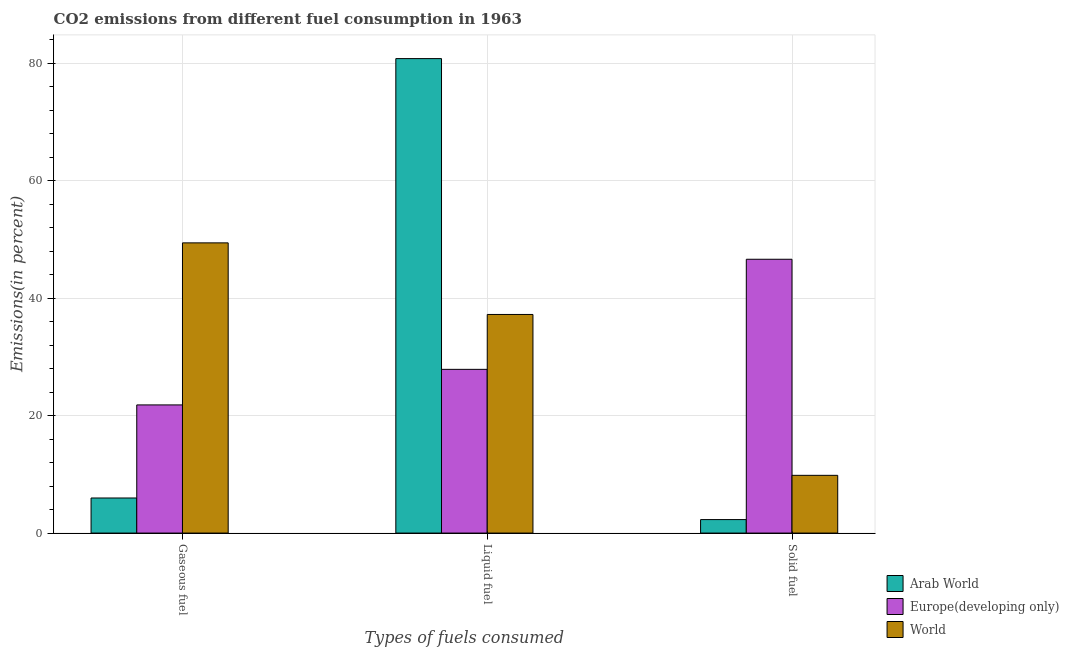How many different coloured bars are there?
Offer a very short reply. 3. Are the number of bars per tick equal to the number of legend labels?
Your answer should be very brief. Yes. Are the number of bars on each tick of the X-axis equal?
Offer a very short reply. Yes. What is the label of the 2nd group of bars from the left?
Offer a very short reply. Liquid fuel. What is the percentage of liquid fuel emission in Arab World?
Your response must be concise. 80.82. Across all countries, what is the maximum percentage of liquid fuel emission?
Offer a terse response. 80.82. Across all countries, what is the minimum percentage of liquid fuel emission?
Your response must be concise. 27.89. In which country was the percentage of liquid fuel emission maximum?
Offer a terse response. Arab World. In which country was the percentage of solid fuel emission minimum?
Make the answer very short. Arab World. What is the total percentage of solid fuel emission in the graph?
Offer a terse response. 58.77. What is the difference between the percentage of gaseous fuel emission in Arab World and that in Europe(developing only)?
Make the answer very short. -15.85. What is the difference between the percentage of gaseous fuel emission in Europe(developing only) and the percentage of liquid fuel emission in Arab World?
Provide a short and direct response. -58.99. What is the average percentage of gaseous fuel emission per country?
Keep it short and to the point. 25.75. What is the difference between the percentage of solid fuel emission and percentage of gaseous fuel emission in World?
Your response must be concise. -39.6. In how many countries, is the percentage of liquid fuel emission greater than 76 %?
Provide a short and direct response. 1. What is the ratio of the percentage of solid fuel emission in Europe(developing only) to that in Arab World?
Make the answer very short. 20.31. What is the difference between the highest and the second highest percentage of solid fuel emission?
Offer a very short reply. 36.81. What is the difference between the highest and the lowest percentage of gaseous fuel emission?
Offer a very short reply. 43.46. Is the sum of the percentage of gaseous fuel emission in Arab World and Europe(developing only) greater than the maximum percentage of liquid fuel emission across all countries?
Give a very brief answer. No. What does the 2nd bar from the left in Solid fuel represents?
Your answer should be very brief. Europe(developing only). What does the 3rd bar from the right in Solid fuel represents?
Your response must be concise. Arab World. Is it the case that in every country, the sum of the percentage of gaseous fuel emission and percentage of liquid fuel emission is greater than the percentage of solid fuel emission?
Provide a succinct answer. Yes. Are all the bars in the graph horizontal?
Give a very brief answer. No. How many countries are there in the graph?
Provide a succinct answer. 3. Are the values on the major ticks of Y-axis written in scientific E-notation?
Make the answer very short. No. Does the graph contain any zero values?
Give a very brief answer. No. Where does the legend appear in the graph?
Give a very brief answer. Bottom right. How many legend labels are there?
Provide a short and direct response. 3. What is the title of the graph?
Your answer should be very brief. CO2 emissions from different fuel consumption in 1963. Does "Botswana" appear as one of the legend labels in the graph?
Provide a short and direct response. No. What is the label or title of the X-axis?
Keep it short and to the point. Types of fuels consumed. What is the label or title of the Y-axis?
Keep it short and to the point. Emissions(in percent). What is the Emissions(in percent) in Arab World in Gaseous fuel?
Provide a succinct answer. 5.98. What is the Emissions(in percent) of Europe(developing only) in Gaseous fuel?
Your answer should be compact. 21.83. What is the Emissions(in percent) of World in Gaseous fuel?
Give a very brief answer. 49.43. What is the Emissions(in percent) in Arab World in Liquid fuel?
Your answer should be compact. 80.82. What is the Emissions(in percent) in Europe(developing only) in Liquid fuel?
Ensure brevity in your answer.  27.89. What is the Emissions(in percent) of World in Liquid fuel?
Keep it short and to the point. 37.24. What is the Emissions(in percent) of Arab World in Solid fuel?
Keep it short and to the point. 2.3. What is the Emissions(in percent) of Europe(developing only) in Solid fuel?
Give a very brief answer. 46.64. What is the Emissions(in percent) in World in Solid fuel?
Give a very brief answer. 9.83. Across all Types of fuels consumed, what is the maximum Emissions(in percent) in Arab World?
Give a very brief answer. 80.82. Across all Types of fuels consumed, what is the maximum Emissions(in percent) of Europe(developing only)?
Offer a terse response. 46.64. Across all Types of fuels consumed, what is the maximum Emissions(in percent) of World?
Provide a succinct answer. 49.43. Across all Types of fuels consumed, what is the minimum Emissions(in percent) of Arab World?
Provide a short and direct response. 2.3. Across all Types of fuels consumed, what is the minimum Emissions(in percent) in Europe(developing only)?
Ensure brevity in your answer.  21.83. Across all Types of fuels consumed, what is the minimum Emissions(in percent) of World?
Ensure brevity in your answer.  9.83. What is the total Emissions(in percent) in Arab World in the graph?
Your answer should be compact. 89.1. What is the total Emissions(in percent) in Europe(developing only) in the graph?
Your response must be concise. 96.36. What is the total Emissions(in percent) in World in the graph?
Keep it short and to the point. 96.51. What is the difference between the Emissions(in percent) in Arab World in Gaseous fuel and that in Liquid fuel?
Provide a short and direct response. -74.85. What is the difference between the Emissions(in percent) of Europe(developing only) in Gaseous fuel and that in Liquid fuel?
Provide a succinct answer. -6.06. What is the difference between the Emissions(in percent) in World in Gaseous fuel and that in Liquid fuel?
Provide a succinct answer. 12.19. What is the difference between the Emissions(in percent) in Arab World in Gaseous fuel and that in Solid fuel?
Your answer should be compact. 3.68. What is the difference between the Emissions(in percent) in Europe(developing only) in Gaseous fuel and that in Solid fuel?
Your answer should be compact. -24.81. What is the difference between the Emissions(in percent) in World in Gaseous fuel and that in Solid fuel?
Offer a terse response. 39.6. What is the difference between the Emissions(in percent) in Arab World in Liquid fuel and that in Solid fuel?
Your answer should be very brief. 78.52. What is the difference between the Emissions(in percent) in Europe(developing only) in Liquid fuel and that in Solid fuel?
Your answer should be very brief. -18.75. What is the difference between the Emissions(in percent) in World in Liquid fuel and that in Solid fuel?
Your answer should be very brief. 27.41. What is the difference between the Emissions(in percent) in Arab World in Gaseous fuel and the Emissions(in percent) in Europe(developing only) in Liquid fuel?
Provide a succinct answer. -21.91. What is the difference between the Emissions(in percent) in Arab World in Gaseous fuel and the Emissions(in percent) in World in Liquid fuel?
Give a very brief answer. -31.26. What is the difference between the Emissions(in percent) in Europe(developing only) in Gaseous fuel and the Emissions(in percent) in World in Liquid fuel?
Keep it short and to the point. -15.41. What is the difference between the Emissions(in percent) in Arab World in Gaseous fuel and the Emissions(in percent) in Europe(developing only) in Solid fuel?
Provide a short and direct response. -40.67. What is the difference between the Emissions(in percent) of Arab World in Gaseous fuel and the Emissions(in percent) of World in Solid fuel?
Provide a succinct answer. -3.86. What is the difference between the Emissions(in percent) of Europe(developing only) in Gaseous fuel and the Emissions(in percent) of World in Solid fuel?
Provide a short and direct response. 11.99. What is the difference between the Emissions(in percent) of Arab World in Liquid fuel and the Emissions(in percent) of Europe(developing only) in Solid fuel?
Ensure brevity in your answer.  34.18. What is the difference between the Emissions(in percent) in Arab World in Liquid fuel and the Emissions(in percent) in World in Solid fuel?
Your answer should be very brief. 70.99. What is the difference between the Emissions(in percent) of Europe(developing only) in Liquid fuel and the Emissions(in percent) of World in Solid fuel?
Provide a short and direct response. 18.05. What is the average Emissions(in percent) of Arab World per Types of fuels consumed?
Give a very brief answer. 29.7. What is the average Emissions(in percent) of Europe(developing only) per Types of fuels consumed?
Keep it short and to the point. 32.12. What is the average Emissions(in percent) in World per Types of fuels consumed?
Keep it short and to the point. 32.17. What is the difference between the Emissions(in percent) of Arab World and Emissions(in percent) of Europe(developing only) in Gaseous fuel?
Offer a very short reply. -15.85. What is the difference between the Emissions(in percent) in Arab World and Emissions(in percent) in World in Gaseous fuel?
Your answer should be compact. -43.46. What is the difference between the Emissions(in percent) in Europe(developing only) and Emissions(in percent) in World in Gaseous fuel?
Provide a short and direct response. -27.6. What is the difference between the Emissions(in percent) of Arab World and Emissions(in percent) of Europe(developing only) in Liquid fuel?
Give a very brief answer. 52.93. What is the difference between the Emissions(in percent) in Arab World and Emissions(in percent) in World in Liquid fuel?
Provide a succinct answer. 43.58. What is the difference between the Emissions(in percent) of Europe(developing only) and Emissions(in percent) of World in Liquid fuel?
Provide a short and direct response. -9.35. What is the difference between the Emissions(in percent) in Arab World and Emissions(in percent) in Europe(developing only) in Solid fuel?
Offer a very short reply. -44.34. What is the difference between the Emissions(in percent) of Arab World and Emissions(in percent) of World in Solid fuel?
Provide a short and direct response. -7.54. What is the difference between the Emissions(in percent) in Europe(developing only) and Emissions(in percent) in World in Solid fuel?
Offer a terse response. 36.81. What is the ratio of the Emissions(in percent) in Arab World in Gaseous fuel to that in Liquid fuel?
Offer a terse response. 0.07. What is the ratio of the Emissions(in percent) of Europe(developing only) in Gaseous fuel to that in Liquid fuel?
Your answer should be compact. 0.78. What is the ratio of the Emissions(in percent) in World in Gaseous fuel to that in Liquid fuel?
Give a very brief answer. 1.33. What is the ratio of the Emissions(in percent) in Arab World in Gaseous fuel to that in Solid fuel?
Your answer should be compact. 2.6. What is the ratio of the Emissions(in percent) of Europe(developing only) in Gaseous fuel to that in Solid fuel?
Provide a succinct answer. 0.47. What is the ratio of the Emissions(in percent) in World in Gaseous fuel to that in Solid fuel?
Keep it short and to the point. 5.03. What is the ratio of the Emissions(in percent) of Arab World in Liquid fuel to that in Solid fuel?
Your response must be concise. 35.19. What is the ratio of the Emissions(in percent) in Europe(developing only) in Liquid fuel to that in Solid fuel?
Your response must be concise. 0.6. What is the ratio of the Emissions(in percent) of World in Liquid fuel to that in Solid fuel?
Keep it short and to the point. 3.79. What is the difference between the highest and the second highest Emissions(in percent) in Arab World?
Keep it short and to the point. 74.85. What is the difference between the highest and the second highest Emissions(in percent) in Europe(developing only)?
Your answer should be very brief. 18.75. What is the difference between the highest and the second highest Emissions(in percent) in World?
Make the answer very short. 12.19. What is the difference between the highest and the lowest Emissions(in percent) in Arab World?
Provide a short and direct response. 78.52. What is the difference between the highest and the lowest Emissions(in percent) of Europe(developing only)?
Your answer should be very brief. 24.81. What is the difference between the highest and the lowest Emissions(in percent) of World?
Offer a very short reply. 39.6. 